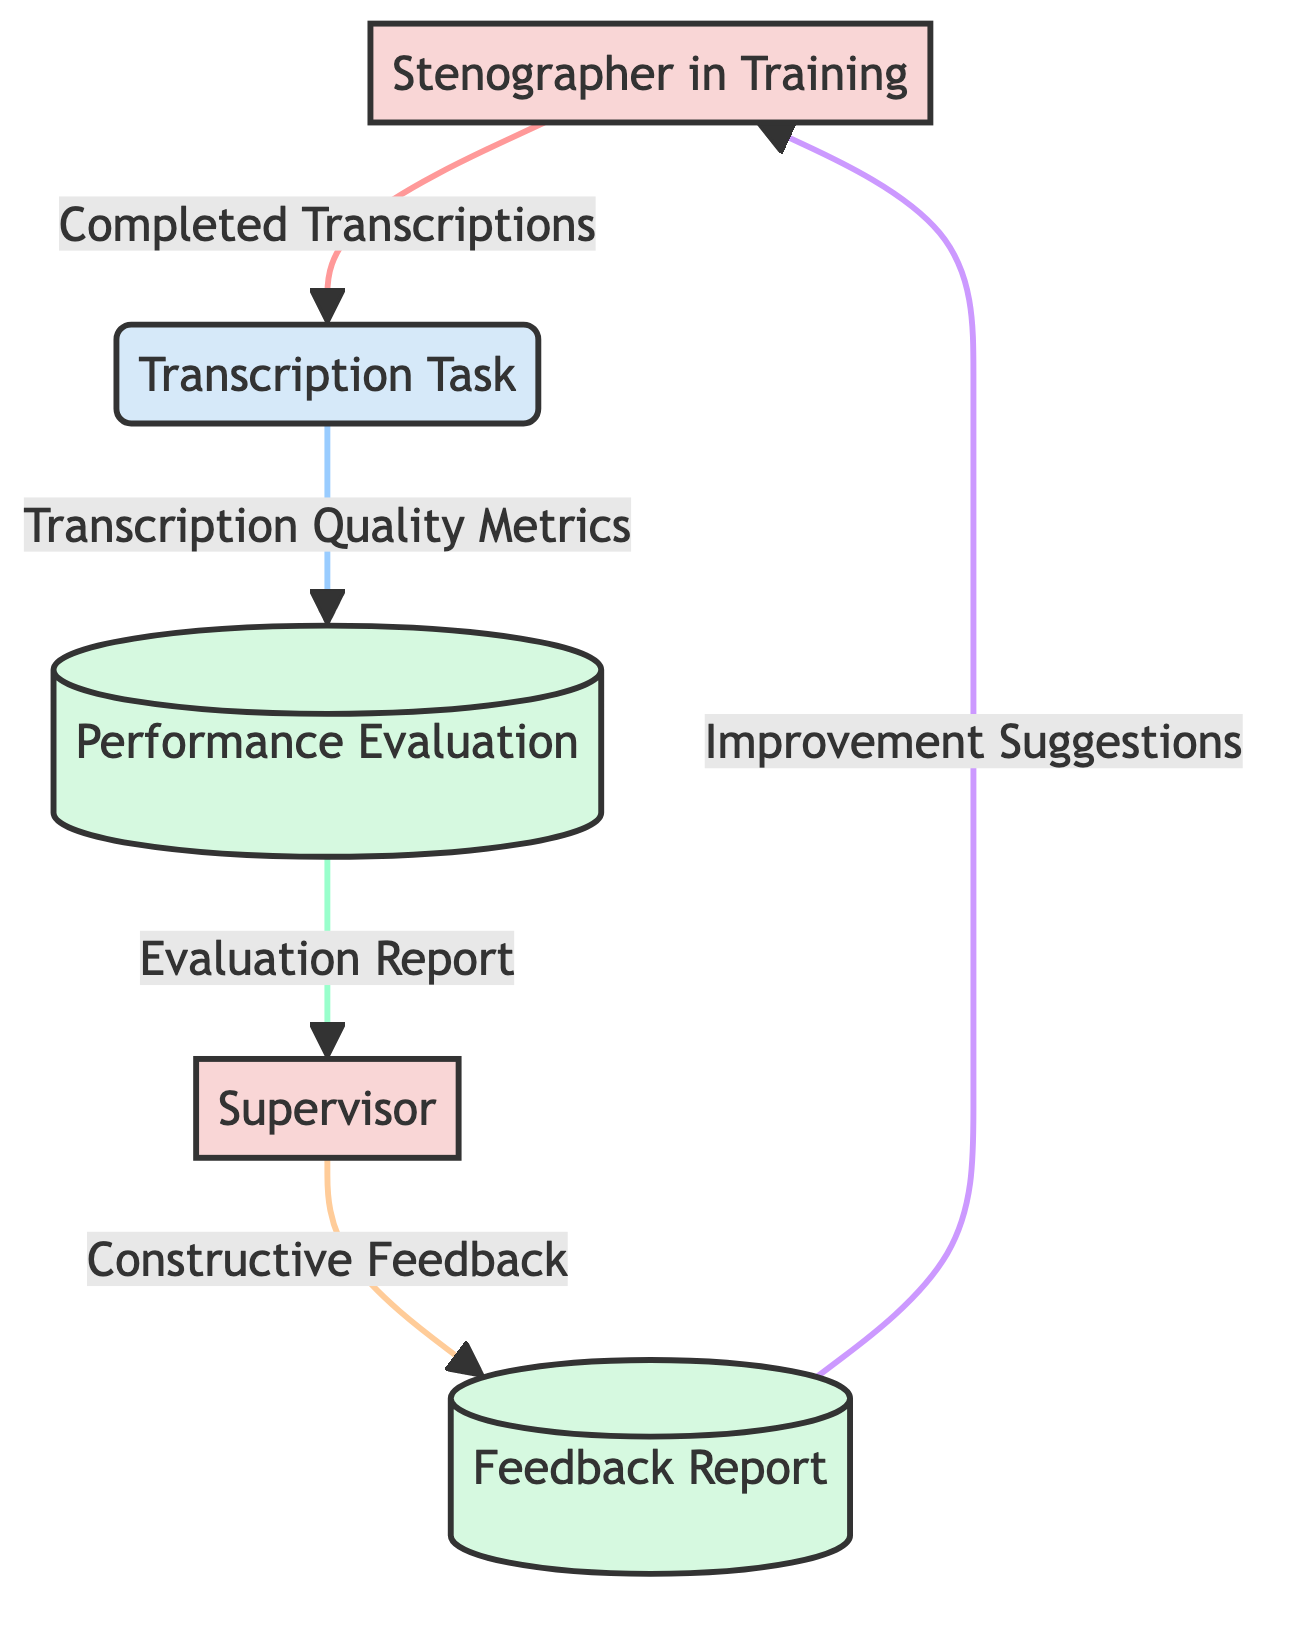What is the first entity that provides input to the transcription task? The first entity in the flow that provides input is the "Stenographer in Training," which sends "Completed Transcriptions" to the "Transcription Task."
Answer: Stenographer in Training How many external entities are present in the diagram? There are two external entities in the diagram: the "Stenographer in Training" and the "Supervisor."
Answer: 2 What type of data does the transcription task send to the performance evaluation? The "Transcription Task" sends "Transcription Quality Metrics" to the "Performance Evaluation," indicating the quality of the completed work.
Answer: Transcription Quality Metrics What data does the supervisor provide to the feedback report? The supervisor provides "Constructive Feedback" to the "Feedback Report," which contains suggestions for improvement based on the evaluation.
Answer: Constructive Feedback In which data store is the evaluation report located after the performance evaluation? The "Evaluation Report" is stored in the "Performance Evaluation," which acts as a data store for the assessment outcomes.
Answer: Performance Evaluation What is the last data flow leading to the stenographer in training? The last data flow going to the stenographer in training is "Improvement Suggestions" coming from the "Feedback Report."
Answer: Improvement Suggestions Which process is responsible for evaluating the transcription quality? The process responsible for evaluating the transcription quality is the "Performance Evaluation," which analyzes the quality metrics obtained from the transcription task.
Answer: Performance Evaluation What is the role of the supervisor in this feedback loop? The role of the supervisor is to evaluate the performance and provide constructive feedback to the stenographer in training, facilitating skill improvement.
Answer: Evaluation and feedback 